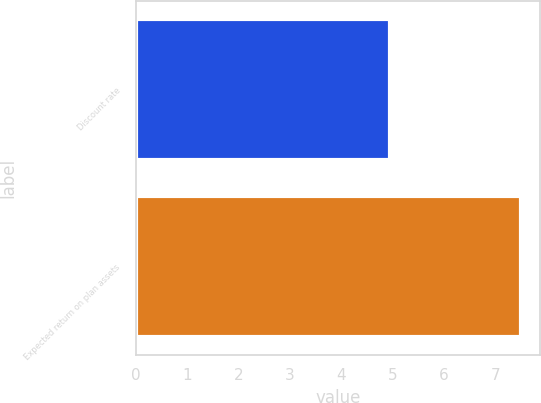Convert chart to OTSL. <chart><loc_0><loc_0><loc_500><loc_500><bar_chart><fcel>Discount rate<fcel>Expected return on plan assets<nl><fcel>4.95<fcel>7.5<nl></chart> 